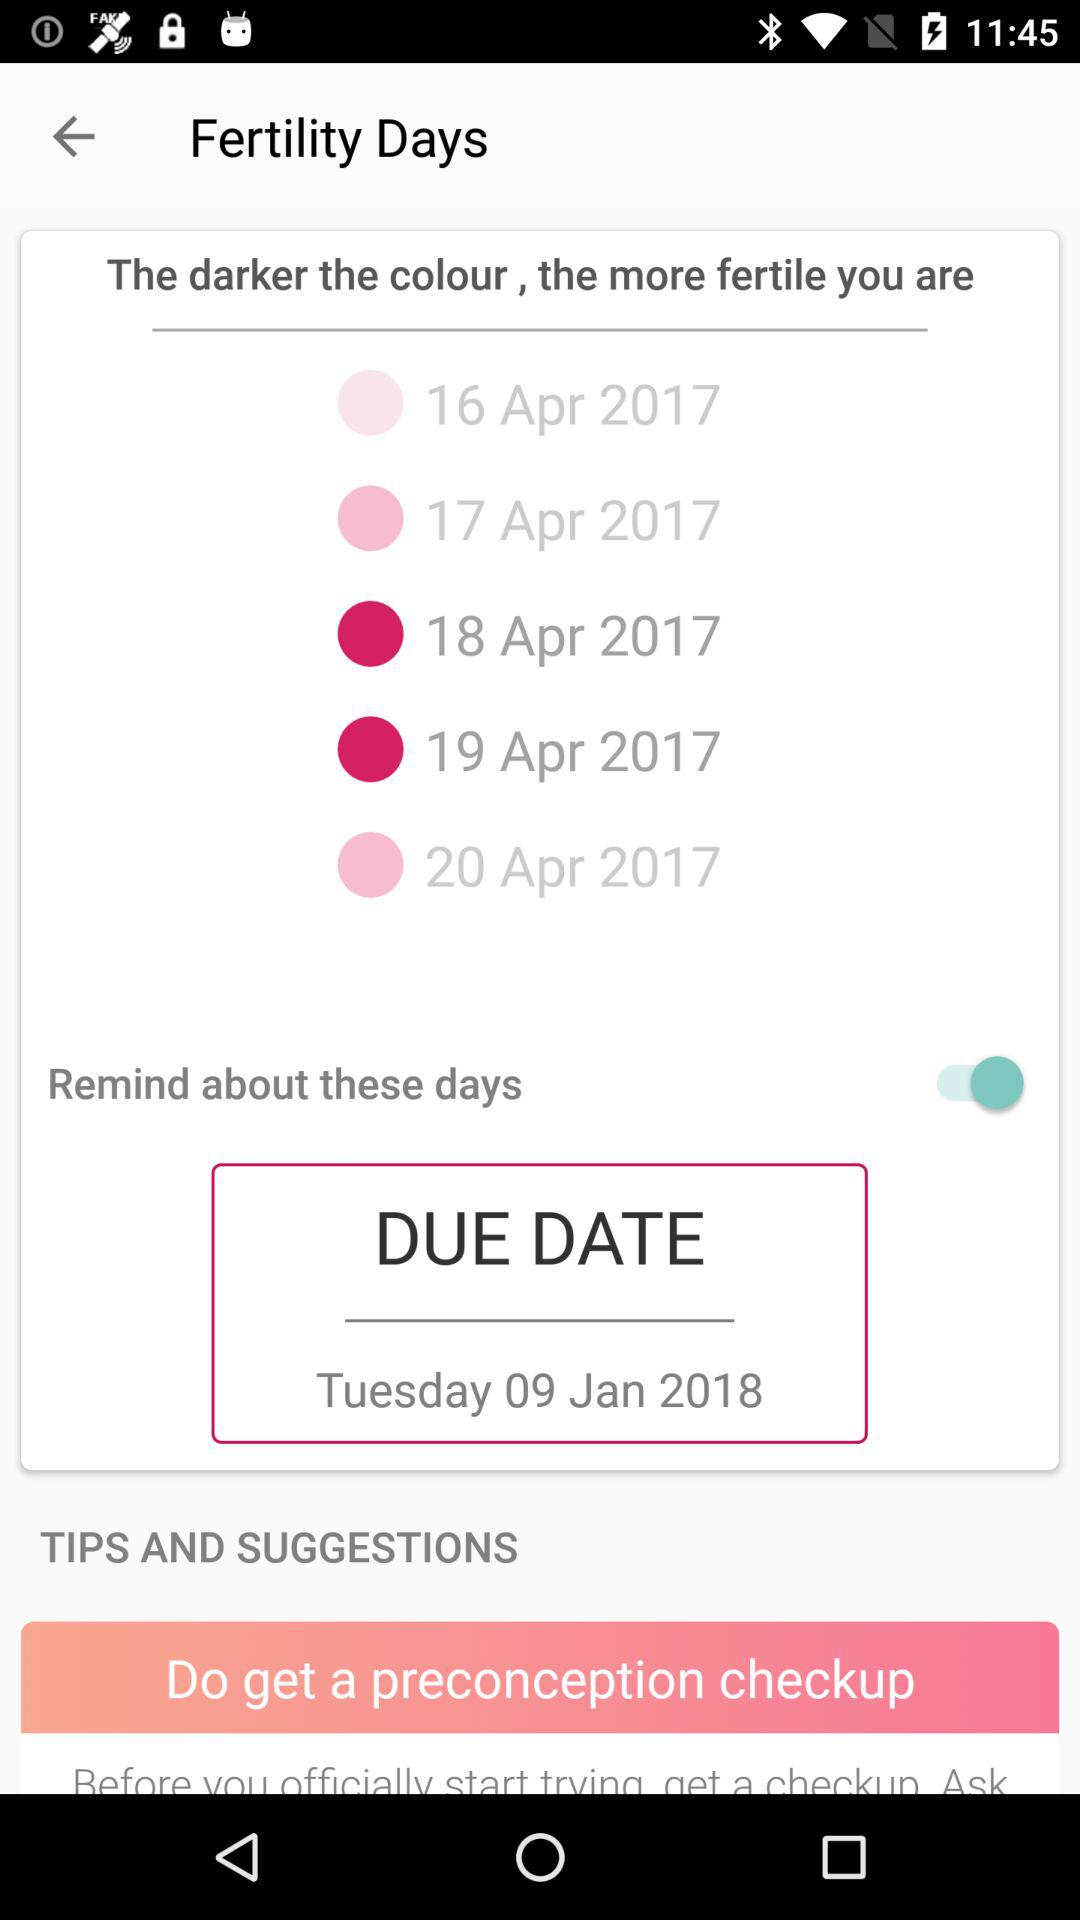What is the status of "Remind about these days"? The status is "on". 